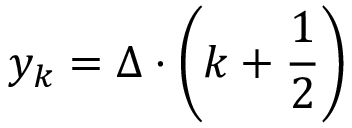Convert formula to latex. <formula><loc_0><loc_0><loc_500><loc_500>y _ { k } = \Delta \cdot \left ( k + { \frac { 1 } { 2 } } \right )</formula> 